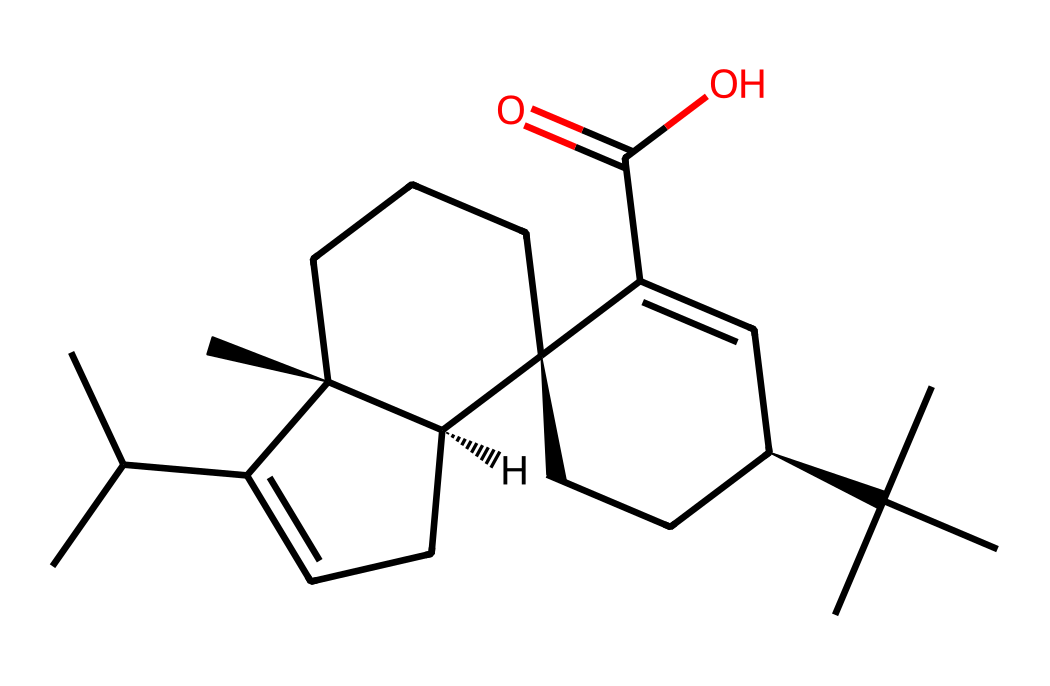What is the chemical formula for the compound shown in the SMILES? The chemical formula can be deduced by counting the number of carbon (C), hydrogen (H), and oxygen (O) atoms represented in the structure from the SMILES. For the provided chemical, there are 24 carbon atoms, 38 hydrogen atoms, and 2 oxygen atoms, resulting in the chemical formula C24H38O2.
Answer: C24H38O2 How many carbon atoms are in this compound? A visual inspection of the SMILES representation shows that the compound includes 24 instances of the carbon atom symbol (C). Thus, the total count of carbon atoms is 24.
Answer: 24 What type of liquid is this compound associated with? Given the context of the question regarding violin bows, this compound is identified as a type of liquid rosin, which is known for its stickiness and ability to create friction on bow strings.
Answer: liquid rosin Does this compound contain any functional groups? The presence of a carboxylic acid group (–COOH) can be inferred from the part of the structure that ends with C(=O)O. This indicates that there is at least one functional group present, specifically a carboxylic acid.
Answer: yes Is this compound typically polar or nonpolar? The structure features long hydrocarbon chains and a carboxylic acid group. Although the carboxylic acid contributes some polarity, the larger nonpolar hydrocarbon component dominates, making the compound primarily nonpolar.
Answer: nonpolar What effect does this chemical structure have on its viscosity? The bulky structure with multiple carbon chains and rings contributes to higher molecular weight and greater intermolecular forces, resulting in increased viscosity compared to simpler compounds.
Answer: high viscosity 